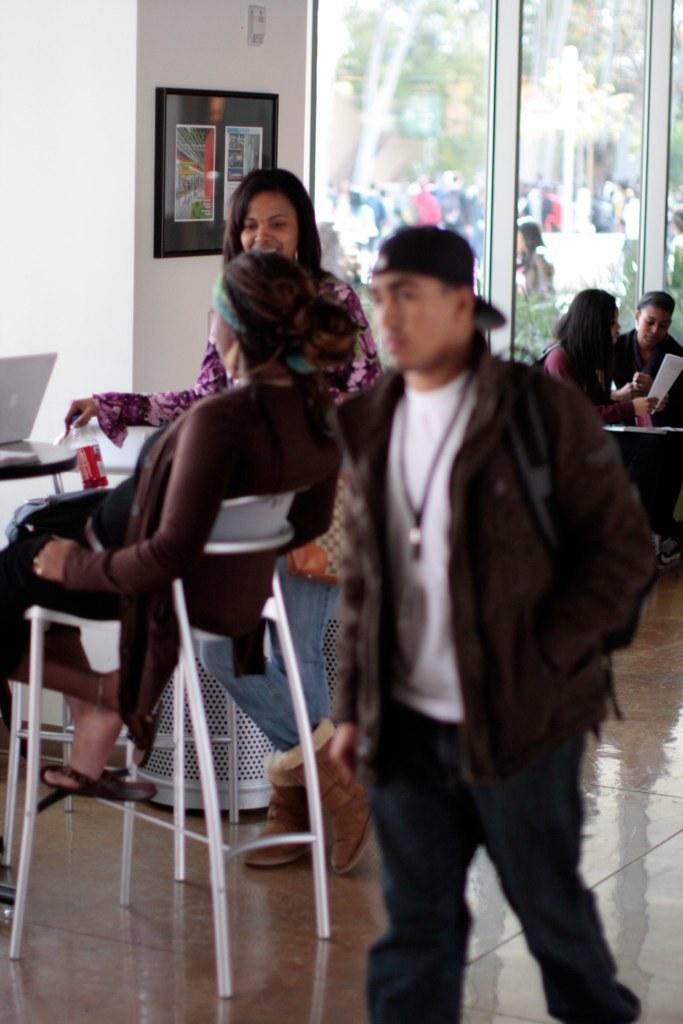Describe this image in one or two sentences. In the foreground of the image, there are three persons. Out of which one person is sitting on the chair in front of the table, on which laptop is kept and two of them are standing. In the background middle of the image there are two person sitting on the chair. In the background, there are group of people standing in front of the tree. In the left there is a wall which is white in color on which photo frame is there. It looks as if the image is taken inside a room. 